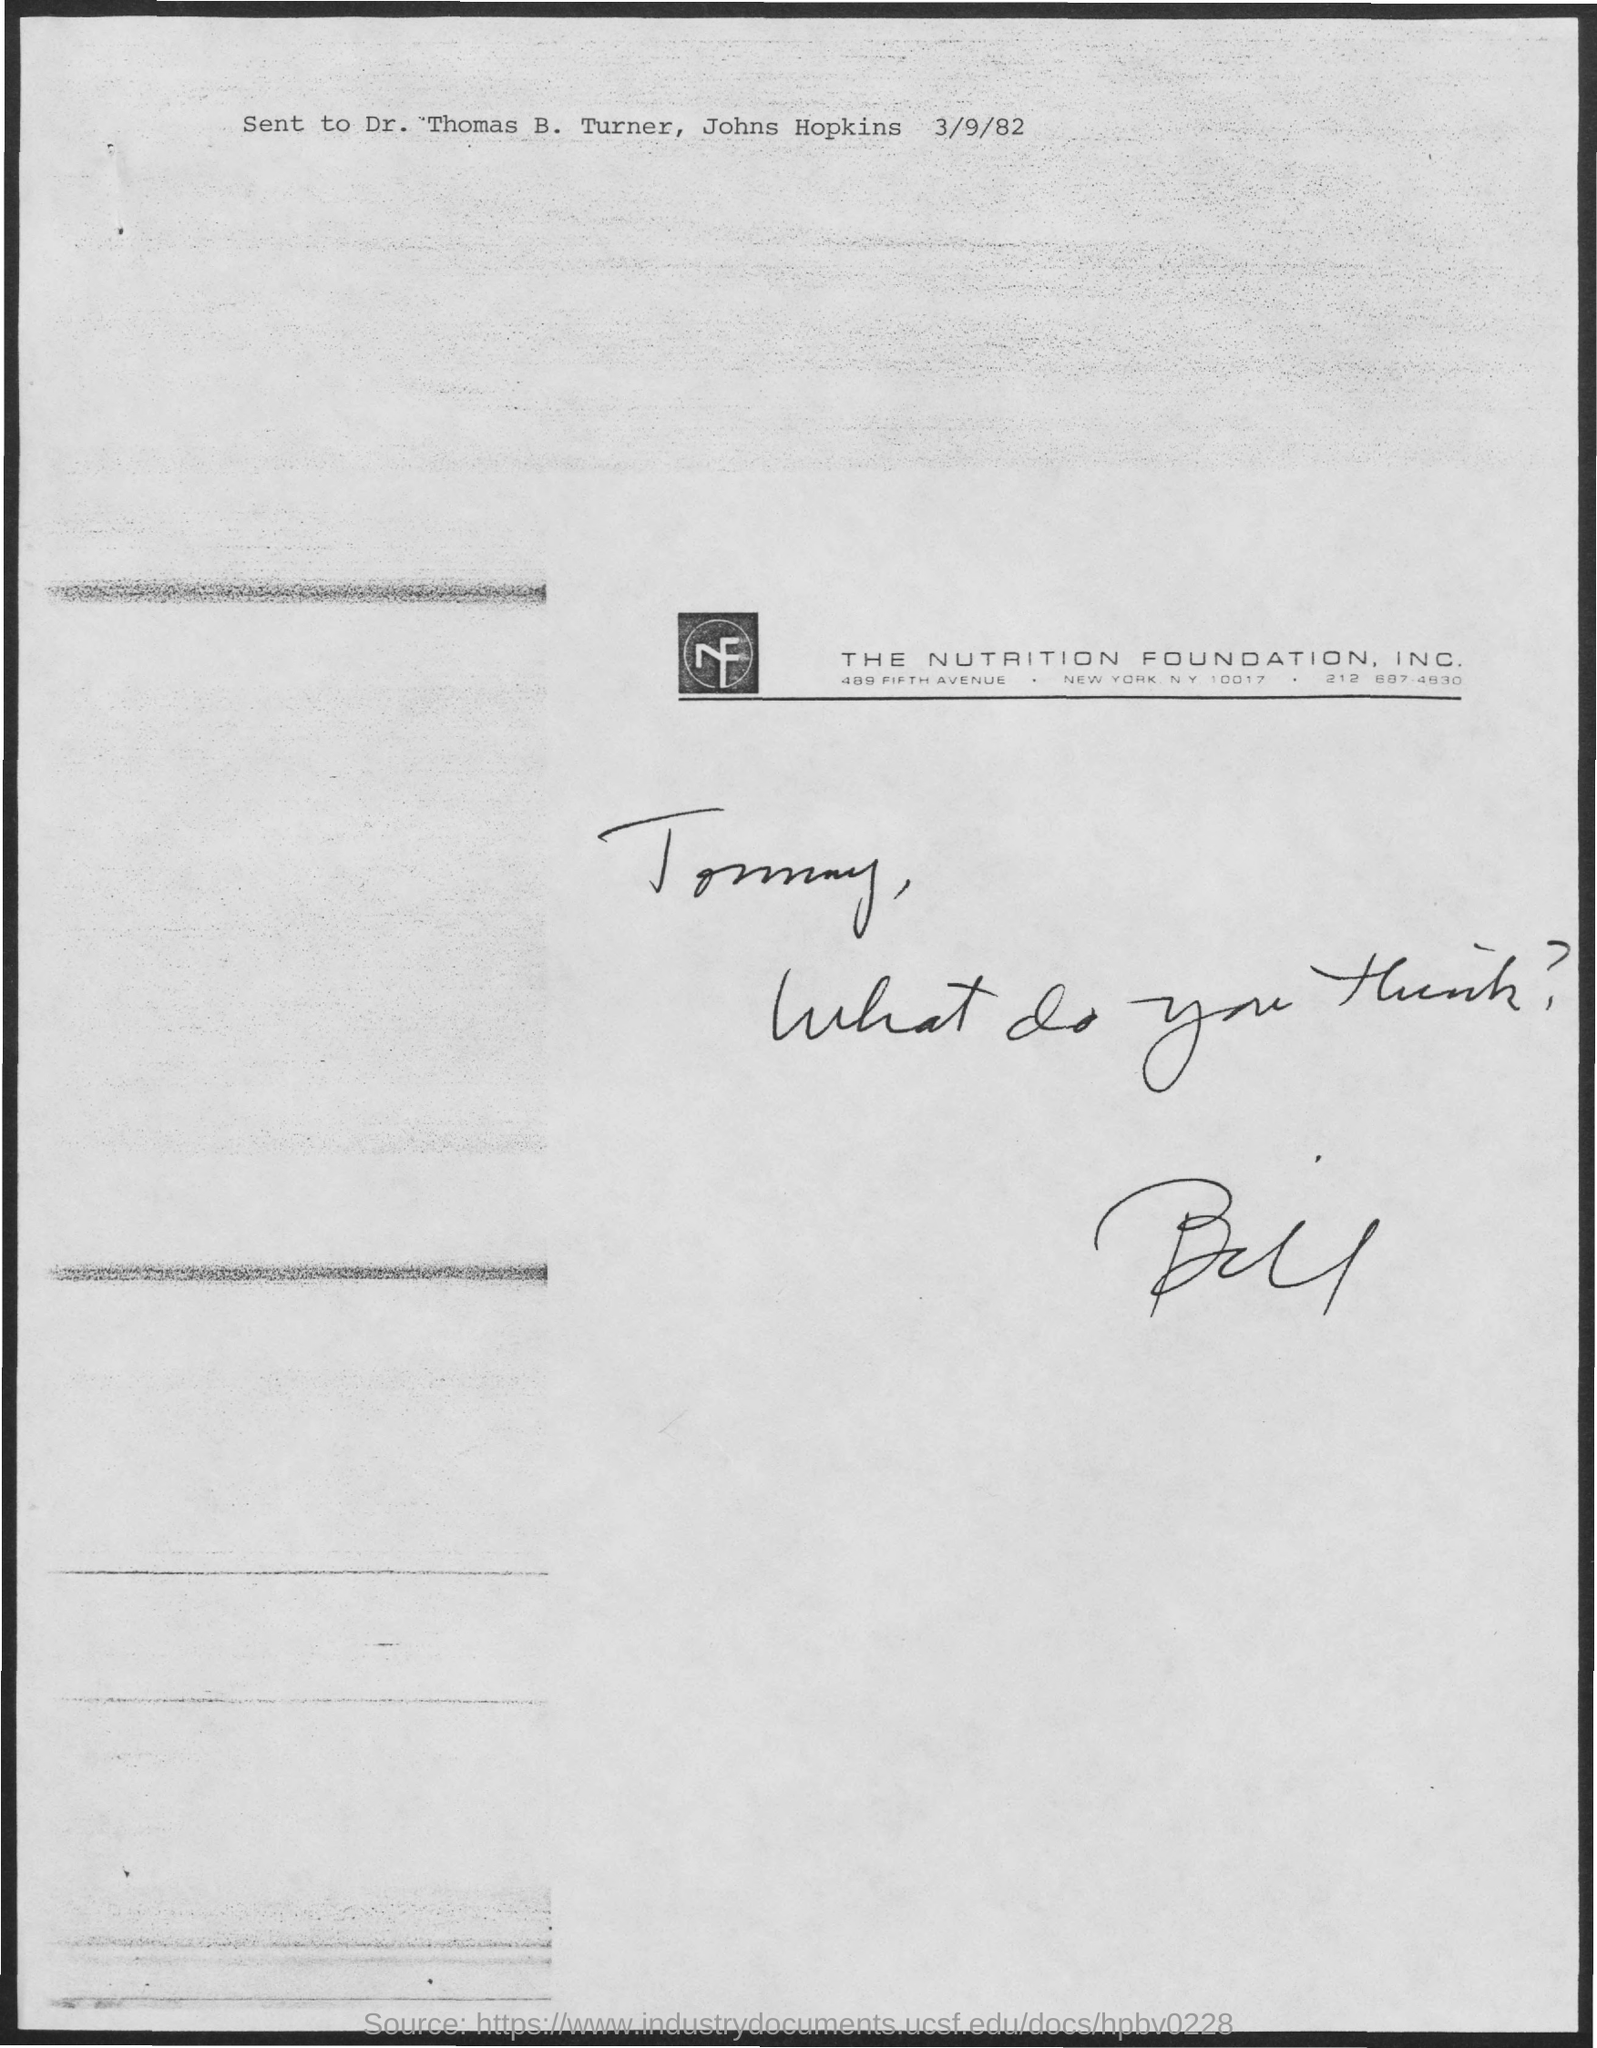What is the date mentioned in the document?
Offer a very short reply. 3/9/82. 